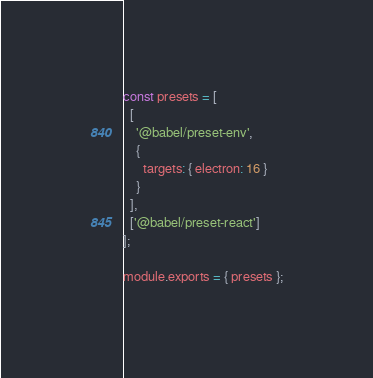Convert code to text. <code><loc_0><loc_0><loc_500><loc_500><_JavaScript_>const presets = [
  [
    '@babel/preset-env',
    {
      targets: { electron: 16 }
    }
  ],
  ['@babel/preset-react']
];

module.exports = { presets };
</code> 